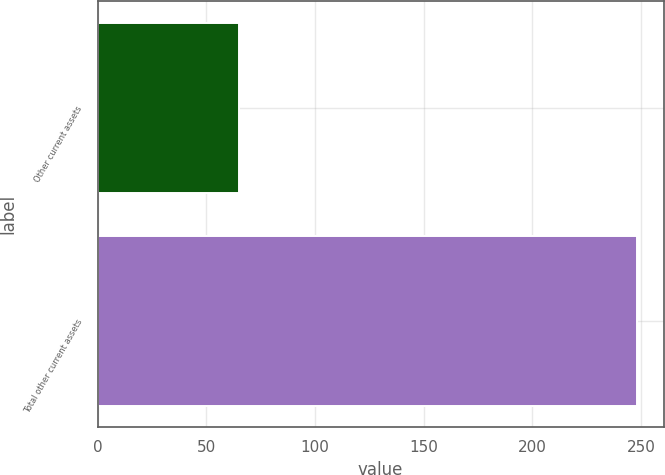<chart> <loc_0><loc_0><loc_500><loc_500><bar_chart><fcel>Other current assets<fcel>Total other current assets<nl><fcel>65<fcel>248<nl></chart> 